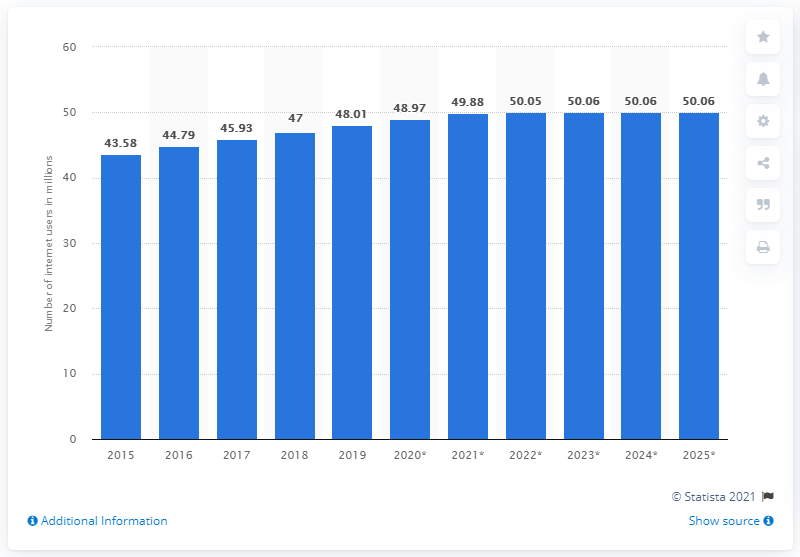Give some essential details in this illustration. By 2025, it is projected that there will be approximately 50.06 million internet users in South Korea. As of 2019, South Korea had 48.01 million internet users. 